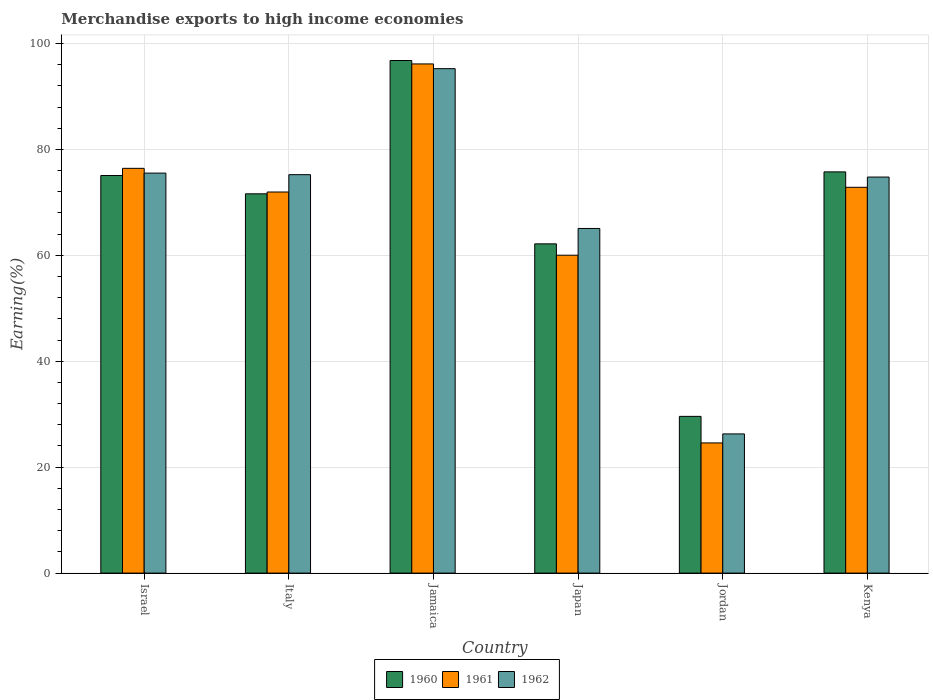How many different coloured bars are there?
Your answer should be very brief. 3. How many groups of bars are there?
Provide a succinct answer. 6. Are the number of bars on each tick of the X-axis equal?
Give a very brief answer. Yes. What is the label of the 5th group of bars from the left?
Your answer should be very brief. Jordan. In how many cases, is the number of bars for a given country not equal to the number of legend labels?
Make the answer very short. 0. What is the percentage of amount earned from merchandise exports in 1960 in Jamaica?
Keep it short and to the point. 96.78. Across all countries, what is the maximum percentage of amount earned from merchandise exports in 1960?
Give a very brief answer. 96.78. Across all countries, what is the minimum percentage of amount earned from merchandise exports in 1962?
Offer a terse response. 26.28. In which country was the percentage of amount earned from merchandise exports in 1960 maximum?
Your answer should be compact. Jamaica. In which country was the percentage of amount earned from merchandise exports in 1962 minimum?
Keep it short and to the point. Jordan. What is the total percentage of amount earned from merchandise exports in 1962 in the graph?
Keep it short and to the point. 412.11. What is the difference between the percentage of amount earned from merchandise exports in 1961 in Italy and that in Kenya?
Ensure brevity in your answer.  -0.89. What is the difference between the percentage of amount earned from merchandise exports in 1961 in Italy and the percentage of amount earned from merchandise exports in 1962 in Japan?
Your answer should be very brief. 6.88. What is the average percentage of amount earned from merchandise exports in 1962 per country?
Ensure brevity in your answer.  68.69. What is the difference between the percentage of amount earned from merchandise exports of/in 1961 and percentage of amount earned from merchandise exports of/in 1960 in Italy?
Provide a short and direct response. 0.34. What is the ratio of the percentage of amount earned from merchandise exports in 1962 in Jordan to that in Kenya?
Your response must be concise. 0.35. Is the percentage of amount earned from merchandise exports in 1960 in Jamaica less than that in Kenya?
Provide a short and direct response. No. What is the difference between the highest and the second highest percentage of amount earned from merchandise exports in 1960?
Your answer should be very brief. 21.71. What is the difference between the highest and the lowest percentage of amount earned from merchandise exports in 1962?
Provide a short and direct response. 68.96. Is the sum of the percentage of amount earned from merchandise exports in 1961 in Jamaica and Jordan greater than the maximum percentage of amount earned from merchandise exports in 1960 across all countries?
Keep it short and to the point. Yes. How many countries are there in the graph?
Your answer should be very brief. 6. What is the difference between two consecutive major ticks on the Y-axis?
Your answer should be very brief. 20. Does the graph contain grids?
Your answer should be very brief. Yes. How are the legend labels stacked?
Your response must be concise. Horizontal. What is the title of the graph?
Offer a very short reply. Merchandise exports to high income economies. What is the label or title of the Y-axis?
Your response must be concise. Earning(%). What is the Earning(%) in 1960 in Israel?
Your answer should be very brief. 75.07. What is the Earning(%) of 1961 in Israel?
Your response must be concise. 76.42. What is the Earning(%) in 1962 in Israel?
Provide a succinct answer. 75.52. What is the Earning(%) of 1960 in Italy?
Ensure brevity in your answer.  71.61. What is the Earning(%) in 1961 in Italy?
Offer a very short reply. 71.95. What is the Earning(%) in 1962 in Italy?
Provide a succinct answer. 75.23. What is the Earning(%) in 1960 in Jamaica?
Your response must be concise. 96.78. What is the Earning(%) of 1961 in Jamaica?
Your answer should be compact. 96.13. What is the Earning(%) of 1962 in Jamaica?
Provide a succinct answer. 95.24. What is the Earning(%) in 1960 in Japan?
Make the answer very short. 62.16. What is the Earning(%) of 1961 in Japan?
Provide a succinct answer. 60.02. What is the Earning(%) of 1962 in Japan?
Keep it short and to the point. 65.07. What is the Earning(%) of 1960 in Jordan?
Offer a terse response. 29.59. What is the Earning(%) in 1961 in Jordan?
Your answer should be very brief. 24.58. What is the Earning(%) in 1962 in Jordan?
Offer a terse response. 26.28. What is the Earning(%) in 1960 in Kenya?
Your answer should be compact. 75.75. What is the Earning(%) in 1961 in Kenya?
Provide a short and direct response. 72.84. What is the Earning(%) of 1962 in Kenya?
Provide a short and direct response. 74.77. Across all countries, what is the maximum Earning(%) in 1960?
Your answer should be very brief. 96.78. Across all countries, what is the maximum Earning(%) in 1961?
Offer a very short reply. 96.13. Across all countries, what is the maximum Earning(%) in 1962?
Offer a terse response. 95.24. Across all countries, what is the minimum Earning(%) of 1960?
Keep it short and to the point. 29.59. Across all countries, what is the minimum Earning(%) in 1961?
Your answer should be very brief. 24.58. Across all countries, what is the minimum Earning(%) in 1962?
Give a very brief answer. 26.28. What is the total Earning(%) in 1960 in the graph?
Your response must be concise. 410.97. What is the total Earning(%) of 1961 in the graph?
Offer a terse response. 401.94. What is the total Earning(%) of 1962 in the graph?
Provide a succinct answer. 412.11. What is the difference between the Earning(%) in 1960 in Israel and that in Italy?
Provide a succinct answer. 3.46. What is the difference between the Earning(%) in 1961 in Israel and that in Italy?
Ensure brevity in your answer.  4.47. What is the difference between the Earning(%) of 1962 in Israel and that in Italy?
Your response must be concise. 0.29. What is the difference between the Earning(%) in 1960 in Israel and that in Jamaica?
Your answer should be very brief. -21.71. What is the difference between the Earning(%) of 1961 in Israel and that in Jamaica?
Give a very brief answer. -19.71. What is the difference between the Earning(%) in 1962 in Israel and that in Jamaica?
Offer a very short reply. -19.72. What is the difference between the Earning(%) in 1960 in Israel and that in Japan?
Ensure brevity in your answer.  12.91. What is the difference between the Earning(%) in 1961 in Israel and that in Japan?
Your response must be concise. 16.4. What is the difference between the Earning(%) of 1962 in Israel and that in Japan?
Offer a terse response. 10.45. What is the difference between the Earning(%) of 1960 in Israel and that in Jordan?
Provide a succinct answer. 45.48. What is the difference between the Earning(%) in 1961 in Israel and that in Jordan?
Provide a succinct answer. 51.84. What is the difference between the Earning(%) in 1962 in Israel and that in Jordan?
Your response must be concise. 49.24. What is the difference between the Earning(%) in 1960 in Israel and that in Kenya?
Your answer should be very brief. -0.68. What is the difference between the Earning(%) of 1961 in Israel and that in Kenya?
Give a very brief answer. 3.58. What is the difference between the Earning(%) of 1962 in Israel and that in Kenya?
Ensure brevity in your answer.  0.75. What is the difference between the Earning(%) in 1960 in Italy and that in Jamaica?
Give a very brief answer. -25.17. What is the difference between the Earning(%) of 1961 in Italy and that in Jamaica?
Make the answer very short. -24.18. What is the difference between the Earning(%) of 1962 in Italy and that in Jamaica?
Offer a very short reply. -20.01. What is the difference between the Earning(%) of 1960 in Italy and that in Japan?
Keep it short and to the point. 9.45. What is the difference between the Earning(%) of 1961 in Italy and that in Japan?
Ensure brevity in your answer.  11.93. What is the difference between the Earning(%) of 1962 in Italy and that in Japan?
Provide a succinct answer. 10.16. What is the difference between the Earning(%) of 1960 in Italy and that in Jordan?
Give a very brief answer. 42.02. What is the difference between the Earning(%) in 1961 in Italy and that in Jordan?
Your answer should be very brief. 47.38. What is the difference between the Earning(%) in 1962 in Italy and that in Jordan?
Offer a terse response. 48.95. What is the difference between the Earning(%) of 1960 in Italy and that in Kenya?
Your answer should be compact. -4.14. What is the difference between the Earning(%) of 1961 in Italy and that in Kenya?
Your response must be concise. -0.89. What is the difference between the Earning(%) of 1962 in Italy and that in Kenya?
Keep it short and to the point. 0.45. What is the difference between the Earning(%) of 1960 in Jamaica and that in Japan?
Provide a short and direct response. 34.62. What is the difference between the Earning(%) in 1961 in Jamaica and that in Japan?
Provide a succinct answer. 36.12. What is the difference between the Earning(%) of 1962 in Jamaica and that in Japan?
Provide a succinct answer. 30.17. What is the difference between the Earning(%) in 1960 in Jamaica and that in Jordan?
Give a very brief answer. 67.19. What is the difference between the Earning(%) of 1961 in Jamaica and that in Jordan?
Give a very brief answer. 71.56. What is the difference between the Earning(%) of 1962 in Jamaica and that in Jordan?
Ensure brevity in your answer.  68.96. What is the difference between the Earning(%) of 1960 in Jamaica and that in Kenya?
Make the answer very short. 21.03. What is the difference between the Earning(%) in 1961 in Jamaica and that in Kenya?
Keep it short and to the point. 23.3. What is the difference between the Earning(%) in 1962 in Jamaica and that in Kenya?
Make the answer very short. 20.47. What is the difference between the Earning(%) of 1960 in Japan and that in Jordan?
Keep it short and to the point. 32.57. What is the difference between the Earning(%) of 1961 in Japan and that in Jordan?
Your response must be concise. 35.44. What is the difference between the Earning(%) of 1962 in Japan and that in Jordan?
Make the answer very short. 38.79. What is the difference between the Earning(%) in 1960 in Japan and that in Kenya?
Ensure brevity in your answer.  -13.59. What is the difference between the Earning(%) in 1961 in Japan and that in Kenya?
Make the answer very short. -12.82. What is the difference between the Earning(%) in 1962 in Japan and that in Kenya?
Your answer should be compact. -9.7. What is the difference between the Earning(%) of 1960 in Jordan and that in Kenya?
Offer a very short reply. -46.16. What is the difference between the Earning(%) in 1961 in Jordan and that in Kenya?
Offer a terse response. -48.26. What is the difference between the Earning(%) in 1962 in Jordan and that in Kenya?
Ensure brevity in your answer.  -48.5. What is the difference between the Earning(%) of 1960 in Israel and the Earning(%) of 1961 in Italy?
Give a very brief answer. 3.12. What is the difference between the Earning(%) in 1960 in Israel and the Earning(%) in 1962 in Italy?
Offer a very short reply. -0.16. What is the difference between the Earning(%) in 1961 in Israel and the Earning(%) in 1962 in Italy?
Keep it short and to the point. 1.19. What is the difference between the Earning(%) of 1960 in Israel and the Earning(%) of 1961 in Jamaica?
Provide a short and direct response. -21.06. What is the difference between the Earning(%) in 1960 in Israel and the Earning(%) in 1962 in Jamaica?
Ensure brevity in your answer.  -20.17. What is the difference between the Earning(%) in 1961 in Israel and the Earning(%) in 1962 in Jamaica?
Give a very brief answer. -18.82. What is the difference between the Earning(%) of 1960 in Israel and the Earning(%) of 1961 in Japan?
Provide a succinct answer. 15.05. What is the difference between the Earning(%) in 1960 in Israel and the Earning(%) in 1962 in Japan?
Your answer should be compact. 10. What is the difference between the Earning(%) of 1961 in Israel and the Earning(%) of 1962 in Japan?
Ensure brevity in your answer.  11.35. What is the difference between the Earning(%) of 1960 in Israel and the Earning(%) of 1961 in Jordan?
Your response must be concise. 50.49. What is the difference between the Earning(%) of 1960 in Israel and the Earning(%) of 1962 in Jordan?
Offer a terse response. 48.79. What is the difference between the Earning(%) of 1961 in Israel and the Earning(%) of 1962 in Jordan?
Offer a terse response. 50.14. What is the difference between the Earning(%) in 1960 in Israel and the Earning(%) in 1961 in Kenya?
Offer a very short reply. 2.23. What is the difference between the Earning(%) of 1960 in Israel and the Earning(%) of 1962 in Kenya?
Your response must be concise. 0.3. What is the difference between the Earning(%) of 1961 in Israel and the Earning(%) of 1962 in Kenya?
Your answer should be very brief. 1.65. What is the difference between the Earning(%) in 1960 in Italy and the Earning(%) in 1961 in Jamaica?
Provide a short and direct response. -24.52. What is the difference between the Earning(%) in 1960 in Italy and the Earning(%) in 1962 in Jamaica?
Ensure brevity in your answer.  -23.63. What is the difference between the Earning(%) in 1961 in Italy and the Earning(%) in 1962 in Jamaica?
Keep it short and to the point. -23.29. What is the difference between the Earning(%) of 1960 in Italy and the Earning(%) of 1961 in Japan?
Keep it short and to the point. 11.59. What is the difference between the Earning(%) in 1960 in Italy and the Earning(%) in 1962 in Japan?
Ensure brevity in your answer.  6.54. What is the difference between the Earning(%) of 1961 in Italy and the Earning(%) of 1962 in Japan?
Provide a succinct answer. 6.88. What is the difference between the Earning(%) in 1960 in Italy and the Earning(%) in 1961 in Jordan?
Provide a short and direct response. 47.03. What is the difference between the Earning(%) in 1960 in Italy and the Earning(%) in 1962 in Jordan?
Offer a terse response. 45.33. What is the difference between the Earning(%) in 1961 in Italy and the Earning(%) in 1962 in Jordan?
Make the answer very short. 45.67. What is the difference between the Earning(%) in 1960 in Italy and the Earning(%) in 1961 in Kenya?
Offer a very short reply. -1.23. What is the difference between the Earning(%) in 1960 in Italy and the Earning(%) in 1962 in Kenya?
Your response must be concise. -3.16. What is the difference between the Earning(%) of 1961 in Italy and the Earning(%) of 1962 in Kenya?
Provide a short and direct response. -2.82. What is the difference between the Earning(%) of 1960 in Jamaica and the Earning(%) of 1961 in Japan?
Provide a succinct answer. 36.76. What is the difference between the Earning(%) of 1960 in Jamaica and the Earning(%) of 1962 in Japan?
Offer a very short reply. 31.71. What is the difference between the Earning(%) of 1961 in Jamaica and the Earning(%) of 1962 in Japan?
Offer a terse response. 31.06. What is the difference between the Earning(%) in 1960 in Jamaica and the Earning(%) in 1961 in Jordan?
Offer a terse response. 72.2. What is the difference between the Earning(%) in 1960 in Jamaica and the Earning(%) in 1962 in Jordan?
Provide a short and direct response. 70.5. What is the difference between the Earning(%) in 1961 in Jamaica and the Earning(%) in 1962 in Jordan?
Make the answer very short. 69.86. What is the difference between the Earning(%) of 1960 in Jamaica and the Earning(%) of 1961 in Kenya?
Your answer should be compact. 23.94. What is the difference between the Earning(%) of 1960 in Jamaica and the Earning(%) of 1962 in Kenya?
Offer a terse response. 22.01. What is the difference between the Earning(%) of 1961 in Jamaica and the Earning(%) of 1962 in Kenya?
Keep it short and to the point. 21.36. What is the difference between the Earning(%) in 1960 in Japan and the Earning(%) in 1961 in Jordan?
Your answer should be compact. 37.59. What is the difference between the Earning(%) of 1960 in Japan and the Earning(%) of 1962 in Jordan?
Provide a succinct answer. 35.89. What is the difference between the Earning(%) of 1961 in Japan and the Earning(%) of 1962 in Jordan?
Keep it short and to the point. 33.74. What is the difference between the Earning(%) of 1960 in Japan and the Earning(%) of 1961 in Kenya?
Offer a very short reply. -10.68. What is the difference between the Earning(%) of 1960 in Japan and the Earning(%) of 1962 in Kenya?
Keep it short and to the point. -12.61. What is the difference between the Earning(%) in 1961 in Japan and the Earning(%) in 1962 in Kenya?
Your answer should be compact. -14.76. What is the difference between the Earning(%) of 1960 in Jordan and the Earning(%) of 1961 in Kenya?
Give a very brief answer. -43.25. What is the difference between the Earning(%) in 1960 in Jordan and the Earning(%) in 1962 in Kenya?
Provide a short and direct response. -45.18. What is the difference between the Earning(%) in 1961 in Jordan and the Earning(%) in 1962 in Kenya?
Ensure brevity in your answer.  -50.2. What is the average Earning(%) in 1960 per country?
Ensure brevity in your answer.  68.49. What is the average Earning(%) of 1961 per country?
Provide a short and direct response. 66.99. What is the average Earning(%) of 1962 per country?
Offer a terse response. 68.69. What is the difference between the Earning(%) of 1960 and Earning(%) of 1961 in Israel?
Give a very brief answer. -1.35. What is the difference between the Earning(%) of 1960 and Earning(%) of 1962 in Israel?
Offer a very short reply. -0.45. What is the difference between the Earning(%) in 1961 and Earning(%) in 1962 in Israel?
Offer a very short reply. 0.9. What is the difference between the Earning(%) in 1960 and Earning(%) in 1961 in Italy?
Keep it short and to the point. -0.34. What is the difference between the Earning(%) of 1960 and Earning(%) of 1962 in Italy?
Make the answer very short. -3.62. What is the difference between the Earning(%) of 1961 and Earning(%) of 1962 in Italy?
Provide a succinct answer. -3.28. What is the difference between the Earning(%) in 1960 and Earning(%) in 1961 in Jamaica?
Provide a succinct answer. 0.65. What is the difference between the Earning(%) of 1960 and Earning(%) of 1962 in Jamaica?
Your answer should be very brief. 1.54. What is the difference between the Earning(%) of 1961 and Earning(%) of 1962 in Jamaica?
Offer a terse response. 0.89. What is the difference between the Earning(%) of 1960 and Earning(%) of 1961 in Japan?
Keep it short and to the point. 2.15. What is the difference between the Earning(%) of 1960 and Earning(%) of 1962 in Japan?
Your answer should be compact. -2.91. What is the difference between the Earning(%) of 1961 and Earning(%) of 1962 in Japan?
Make the answer very short. -5.05. What is the difference between the Earning(%) in 1960 and Earning(%) in 1961 in Jordan?
Your answer should be very brief. 5.02. What is the difference between the Earning(%) of 1960 and Earning(%) of 1962 in Jordan?
Keep it short and to the point. 3.31. What is the difference between the Earning(%) in 1961 and Earning(%) in 1962 in Jordan?
Your response must be concise. -1.7. What is the difference between the Earning(%) in 1960 and Earning(%) in 1961 in Kenya?
Your answer should be very brief. 2.91. What is the difference between the Earning(%) of 1960 and Earning(%) of 1962 in Kenya?
Offer a terse response. 0.98. What is the difference between the Earning(%) of 1961 and Earning(%) of 1962 in Kenya?
Ensure brevity in your answer.  -1.94. What is the ratio of the Earning(%) in 1960 in Israel to that in Italy?
Your response must be concise. 1.05. What is the ratio of the Earning(%) of 1961 in Israel to that in Italy?
Give a very brief answer. 1.06. What is the ratio of the Earning(%) in 1962 in Israel to that in Italy?
Give a very brief answer. 1. What is the ratio of the Earning(%) in 1960 in Israel to that in Jamaica?
Your answer should be compact. 0.78. What is the ratio of the Earning(%) in 1961 in Israel to that in Jamaica?
Your answer should be compact. 0.79. What is the ratio of the Earning(%) in 1962 in Israel to that in Jamaica?
Provide a succinct answer. 0.79. What is the ratio of the Earning(%) of 1960 in Israel to that in Japan?
Provide a succinct answer. 1.21. What is the ratio of the Earning(%) in 1961 in Israel to that in Japan?
Your response must be concise. 1.27. What is the ratio of the Earning(%) of 1962 in Israel to that in Japan?
Offer a very short reply. 1.16. What is the ratio of the Earning(%) in 1960 in Israel to that in Jordan?
Your answer should be compact. 2.54. What is the ratio of the Earning(%) in 1961 in Israel to that in Jordan?
Ensure brevity in your answer.  3.11. What is the ratio of the Earning(%) in 1962 in Israel to that in Jordan?
Offer a terse response. 2.87. What is the ratio of the Earning(%) in 1961 in Israel to that in Kenya?
Provide a succinct answer. 1.05. What is the ratio of the Earning(%) in 1960 in Italy to that in Jamaica?
Offer a very short reply. 0.74. What is the ratio of the Earning(%) in 1961 in Italy to that in Jamaica?
Provide a succinct answer. 0.75. What is the ratio of the Earning(%) in 1962 in Italy to that in Jamaica?
Your answer should be very brief. 0.79. What is the ratio of the Earning(%) of 1960 in Italy to that in Japan?
Your answer should be compact. 1.15. What is the ratio of the Earning(%) in 1961 in Italy to that in Japan?
Provide a short and direct response. 1.2. What is the ratio of the Earning(%) of 1962 in Italy to that in Japan?
Provide a succinct answer. 1.16. What is the ratio of the Earning(%) in 1960 in Italy to that in Jordan?
Provide a succinct answer. 2.42. What is the ratio of the Earning(%) of 1961 in Italy to that in Jordan?
Ensure brevity in your answer.  2.93. What is the ratio of the Earning(%) of 1962 in Italy to that in Jordan?
Make the answer very short. 2.86. What is the ratio of the Earning(%) of 1960 in Italy to that in Kenya?
Offer a terse response. 0.95. What is the ratio of the Earning(%) in 1961 in Italy to that in Kenya?
Your answer should be very brief. 0.99. What is the ratio of the Earning(%) in 1960 in Jamaica to that in Japan?
Your response must be concise. 1.56. What is the ratio of the Earning(%) of 1961 in Jamaica to that in Japan?
Provide a short and direct response. 1.6. What is the ratio of the Earning(%) in 1962 in Jamaica to that in Japan?
Offer a terse response. 1.46. What is the ratio of the Earning(%) of 1960 in Jamaica to that in Jordan?
Ensure brevity in your answer.  3.27. What is the ratio of the Earning(%) in 1961 in Jamaica to that in Jordan?
Keep it short and to the point. 3.91. What is the ratio of the Earning(%) in 1962 in Jamaica to that in Jordan?
Offer a terse response. 3.62. What is the ratio of the Earning(%) in 1960 in Jamaica to that in Kenya?
Your answer should be very brief. 1.28. What is the ratio of the Earning(%) in 1961 in Jamaica to that in Kenya?
Offer a very short reply. 1.32. What is the ratio of the Earning(%) of 1962 in Jamaica to that in Kenya?
Keep it short and to the point. 1.27. What is the ratio of the Earning(%) in 1960 in Japan to that in Jordan?
Keep it short and to the point. 2.1. What is the ratio of the Earning(%) of 1961 in Japan to that in Jordan?
Give a very brief answer. 2.44. What is the ratio of the Earning(%) of 1962 in Japan to that in Jordan?
Make the answer very short. 2.48. What is the ratio of the Earning(%) of 1960 in Japan to that in Kenya?
Keep it short and to the point. 0.82. What is the ratio of the Earning(%) of 1961 in Japan to that in Kenya?
Offer a very short reply. 0.82. What is the ratio of the Earning(%) of 1962 in Japan to that in Kenya?
Ensure brevity in your answer.  0.87. What is the ratio of the Earning(%) in 1960 in Jordan to that in Kenya?
Provide a succinct answer. 0.39. What is the ratio of the Earning(%) of 1961 in Jordan to that in Kenya?
Ensure brevity in your answer.  0.34. What is the ratio of the Earning(%) in 1962 in Jordan to that in Kenya?
Ensure brevity in your answer.  0.35. What is the difference between the highest and the second highest Earning(%) of 1960?
Provide a succinct answer. 21.03. What is the difference between the highest and the second highest Earning(%) of 1961?
Offer a terse response. 19.71. What is the difference between the highest and the second highest Earning(%) of 1962?
Offer a very short reply. 19.72. What is the difference between the highest and the lowest Earning(%) of 1960?
Give a very brief answer. 67.19. What is the difference between the highest and the lowest Earning(%) in 1961?
Make the answer very short. 71.56. What is the difference between the highest and the lowest Earning(%) of 1962?
Provide a short and direct response. 68.96. 